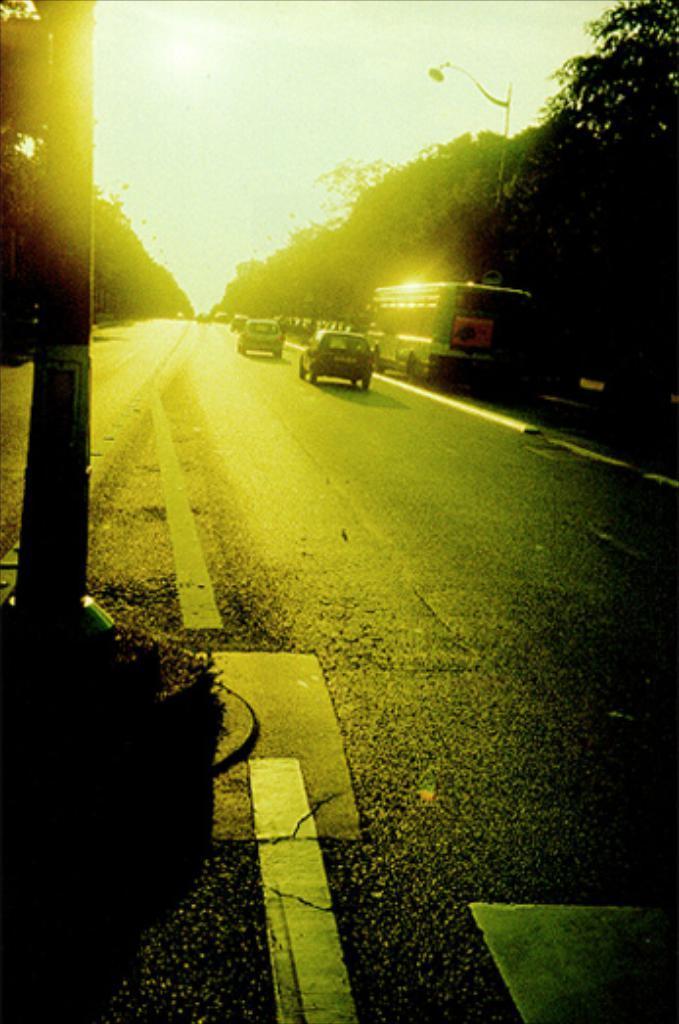Could you give a brief overview of what you see in this image? This image is taken outdoors. At the bottom of the image there is a road. At the top of the image there is a sky. In the middle of the image a few vehicles are moving on the road and a bus is parked on the road. On the left side of the image there is a pole and there are a few trees. On the right side of the image there is a street light and there are many trees. 